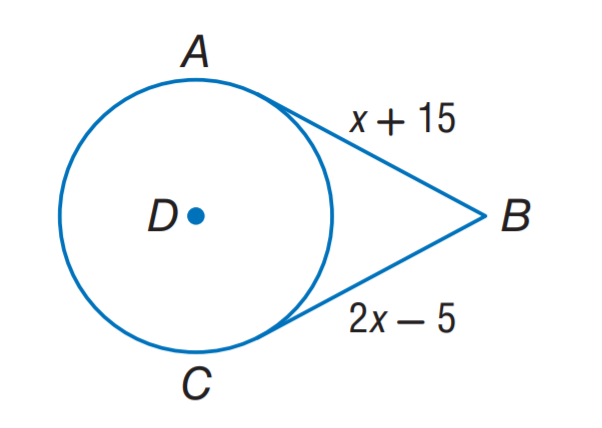Question: A B and C B are tangent to \odot D. Find the value of x.
Choices:
A. 10
B. 15
C. 20
D. 25
Answer with the letter. Answer: C 